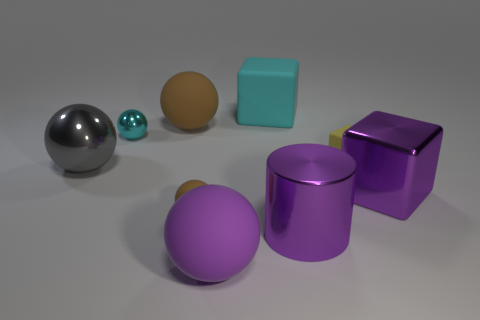Subtract all purple spheres. How many spheres are left? 4 Subtract all gray balls. How many balls are left? 4 Subtract all red spheres. Subtract all yellow blocks. How many spheres are left? 5 Subtract all cylinders. How many objects are left? 8 Add 5 large gray objects. How many large gray objects are left? 6 Add 5 gray metallic things. How many gray metallic things exist? 6 Subtract 0 blue balls. How many objects are left? 9 Subtract all large matte objects. Subtract all big rubber balls. How many objects are left? 4 